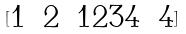<formula> <loc_0><loc_0><loc_500><loc_500>[ \begin{matrix} 1 & 2 & 1 2 3 4 & 4 \\ \end{matrix} ]</formula> 